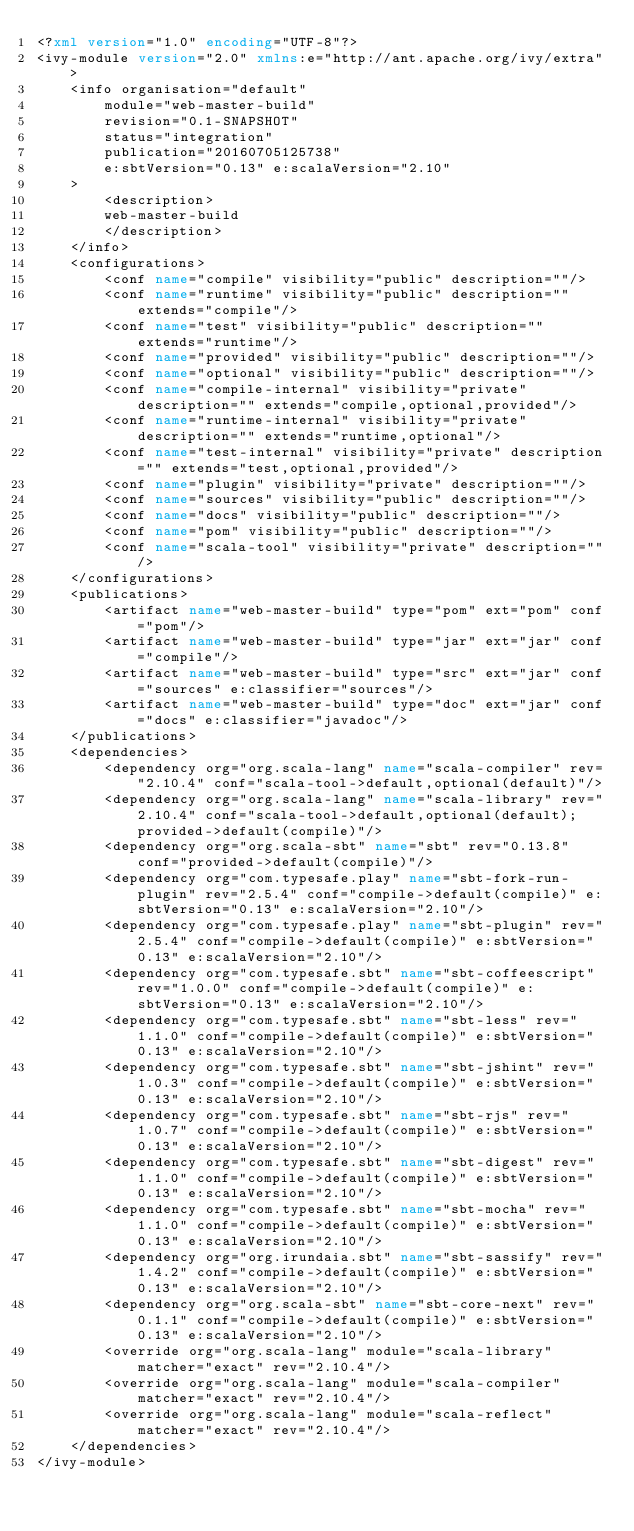<code> <loc_0><loc_0><loc_500><loc_500><_XML_><?xml version="1.0" encoding="UTF-8"?>
<ivy-module version="2.0" xmlns:e="http://ant.apache.org/ivy/extra">
	<info organisation="default"
		module="web-master-build"
		revision="0.1-SNAPSHOT"
		status="integration"
		publication="20160705125738"
		e:sbtVersion="0.13" e:scalaVersion="2.10"
	>
		<description>
		web-master-build
		</description>
	</info>
	<configurations>
		<conf name="compile" visibility="public" description=""/>
		<conf name="runtime" visibility="public" description="" extends="compile"/>
		<conf name="test" visibility="public" description="" extends="runtime"/>
		<conf name="provided" visibility="public" description=""/>
		<conf name="optional" visibility="public" description=""/>
		<conf name="compile-internal" visibility="private" description="" extends="compile,optional,provided"/>
		<conf name="runtime-internal" visibility="private" description="" extends="runtime,optional"/>
		<conf name="test-internal" visibility="private" description="" extends="test,optional,provided"/>
		<conf name="plugin" visibility="private" description=""/>
		<conf name="sources" visibility="public" description=""/>
		<conf name="docs" visibility="public" description=""/>
		<conf name="pom" visibility="public" description=""/>
		<conf name="scala-tool" visibility="private" description=""/>
	</configurations>
	<publications>
		<artifact name="web-master-build" type="pom" ext="pom" conf="pom"/>
		<artifact name="web-master-build" type="jar" ext="jar" conf="compile"/>
		<artifact name="web-master-build" type="src" ext="jar" conf="sources" e:classifier="sources"/>
		<artifact name="web-master-build" type="doc" ext="jar" conf="docs" e:classifier="javadoc"/>
	</publications>
	<dependencies>
		<dependency org="org.scala-lang" name="scala-compiler" rev="2.10.4" conf="scala-tool->default,optional(default)"/>
		<dependency org="org.scala-lang" name="scala-library" rev="2.10.4" conf="scala-tool->default,optional(default);provided->default(compile)"/>
		<dependency org="org.scala-sbt" name="sbt" rev="0.13.8" conf="provided->default(compile)"/>
		<dependency org="com.typesafe.play" name="sbt-fork-run-plugin" rev="2.5.4" conf="compile->default(compile)" e:sbtVersion="0.13" e:scalaVersion="2.10"/>
		<dependency org="com.typesafe.play" name="sbt-plugin" rev="2.5.4" conf="compile->default(compile)" e:sbtVersion="0.13" e:scalaVersion="2.10"/>
		<dependency org="com.typesafe.sbt" name="sbt-coffeescript" rev="1.0.0" conf="compile->default(compile)" e:sbtVersion="0.13" e:scalaVersion="2.10"/>
		<dependency org="com.typesafe.sbt" name="sbt-less" rev="1.1.0" conf="compile->default(compile)" e:sbtVersion="0.13" e:scalaVersion="2.10"/>
		<dependency org="com.typesafe.sbt" name="sbt-jshint" rev="1.0.3" conf="compile->default(compile)" e:sbtVersion="0.13" e:scalaVersion="2.10"/>
		<dependency org="com.typesafe.sbt" name="sbt-rjs" rev="1.0.7" conf="compile->default(compile)" e:sbtVersion="0.13" e:scalaVersion="2.10"/>
		<dependency org="com.typesafe.sbt" name="sbt-digest" rev="1.1.0" conf="compile->default(compile)" e:sbtVersion="0.13" e:scalaVersion="2.10"/>
		<dependency org="com.typesafe.sbt" name="sbt-mocha" rev="1.1.0" conf="compile->default(compile)" e:sbtVersion="0.13" e:scalaVersion="2.10"/>
		<dependency org="org.irundaia.sbt" name="sbt-sassify" rev="1.4.2" conf="compile->default(compile)" e:sbtVersion="0.13" e:scalaVersion="2.10"/>
		<dependency org="org.scala-sbt" name="sbt-core-next" rev="0.1.1" conf="compile->default(compile)" e:sbtVersion="0.13" e:scalaVersion="2.10"/>
		<override org="org.scala-lang" module="scala-library" matcher="exact" rev="2.10.4"/>
		<override org="org.scala-lang" module="scala-compiler" matcher="exact" rev="2.10.4"/>
		<override org="org.scala-lang" module="scala-reflect" matcher="exact" rev="2.10.4"/>
	</dependencies>
</ivy-module>
</code> 